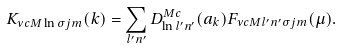Convert formula to latex. <formula><loc_0><loc_0><loc_500><loc_500>K _ { \nu c M \ln \sigma j m } ( k ) = \sum _ { l ^ { \prime } n ^ { \prime } } D ^ { M c } _ { \ln l ^ { \prime } n ^ { \prime } } ( a _ { k } ) F _ { \nu c M l ^ { \prime } n ^ { \prime } \sigma j m } ( \mu ) .</formula> 